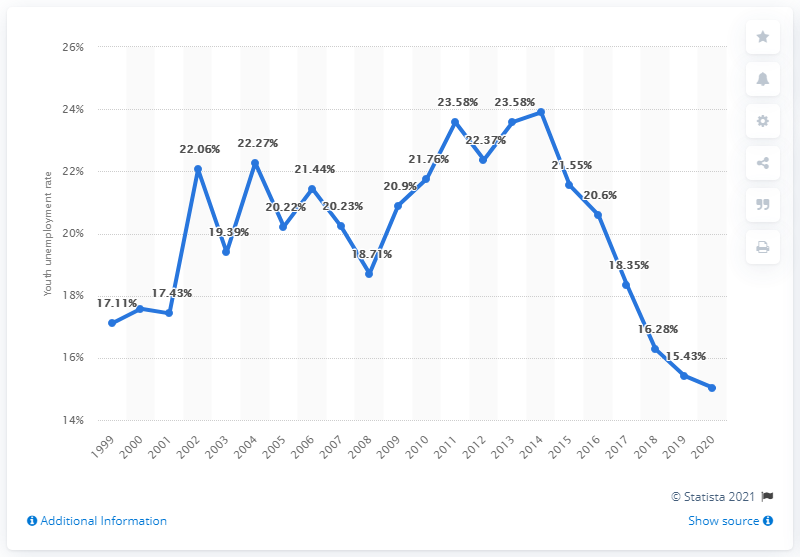Highlight a few significant elements in this photo. In 2020, the youth unemployment rate in Romania was 15.04%. 